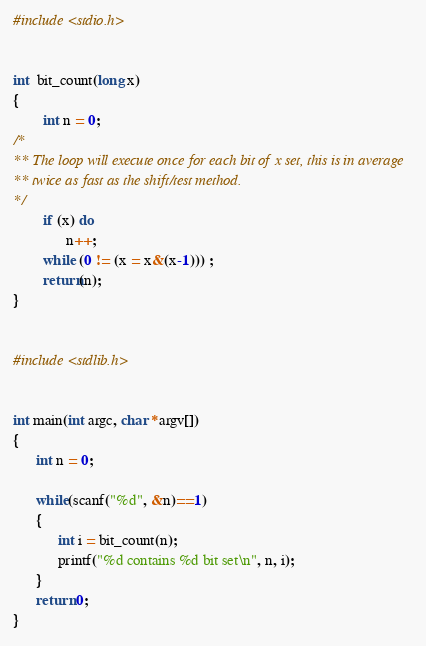<code> <loc_0><loc_0><loc_500><loc_500><_C_>
#include <stdio.h>


int  bit_count(long x)
{
        int n = 0;
/*
** The loop will execute once for each bit of x set, this is in average
** twice as fast as the shift/test method.
*/
        if (x) do
              n++;
        while (0 != (x = x&(x-1))) ;
        return(n);
}


#include <stdlib.h>


int main(int argc, char *argv[])
{
      int n = 0;

      while(scanf("%d", &n)==1)
      {
            int i = bit_count(n);
            printf("%d contains %d bit set\n", n, i);
      }
      return 0;
}


</code> 